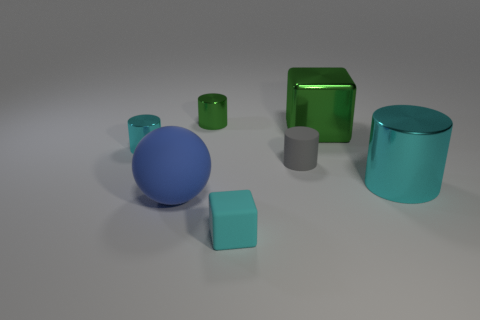How many metal things are the same color as the tiny matte cube?
Your answer should be very brief. 2. There is a small cylinder that is the same color as the rubber block; what material is it?
Your answer should be compact. Metal. Is the green object in front of the green metallic cylinder made of the same material as the gray cylinder?
Keep it short and to the point. No. What number of objects are tiny purple matte cylinders or tiny metal cylinders on the right side of the blue thing?
Keep it short and to the point. 1. There is a green object that is the same shape as the big cyan metallic object; what size is it?
Offer a very short reply. Small. Is there any other thing that has the same size as the green metal cylinder?
Give a very brief answer. Yes. Are there any large cylinders right of the blue matte ball?
Provide a succinct answer. Yes. Do the metal cylinder that is in front of the matte cylinder and the large metal thing that is behind the tiny cyan cylinder have the same color?
Provide a short and direct response. No. Is there a small metallic thing of the same shape as the big green thing?
Your answer should be very brief. No. How many other objects are there of the same color as the tiny matte block?
Ensure brevity in your answer.  2. 